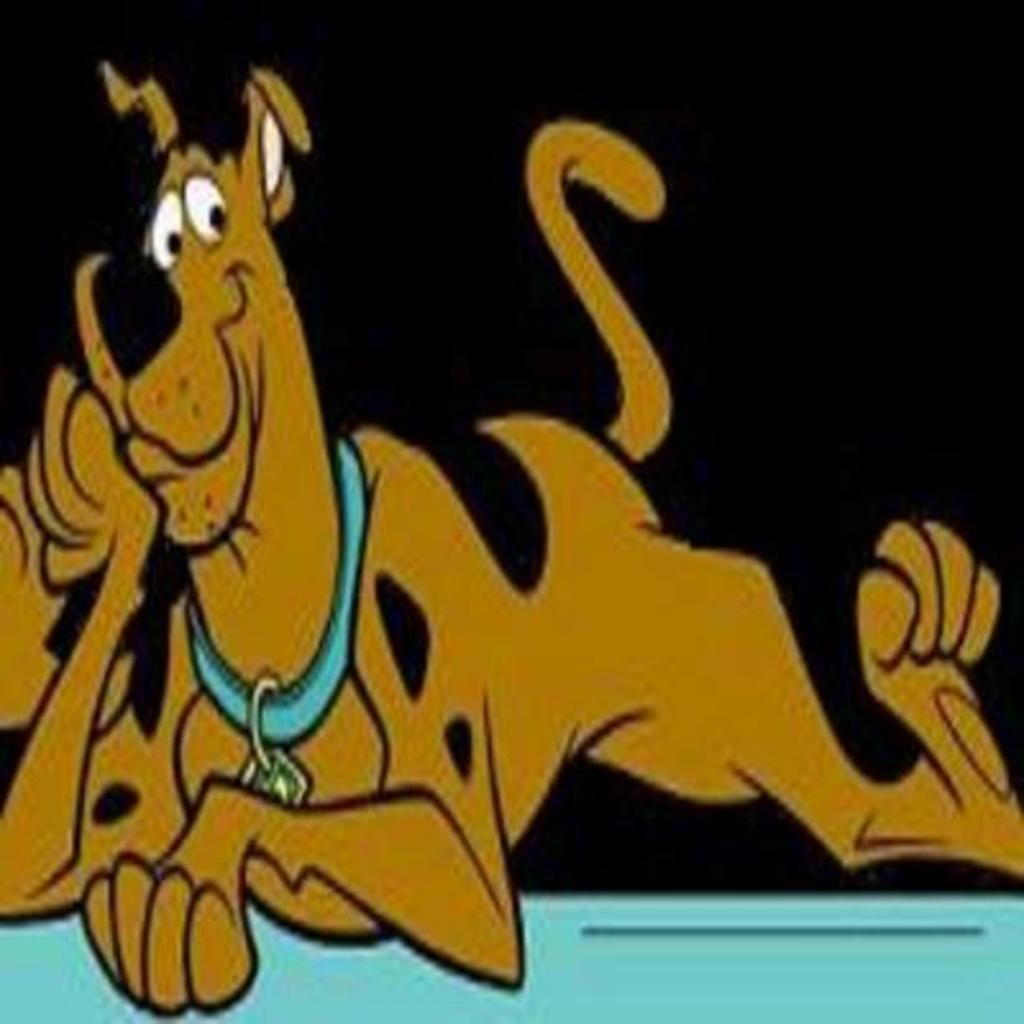What type of animal is depicted in the image? There is a cartoon picture of a dog in the image. What colors are used to represent the dog? The dog is in brown and black colors. How would you describe the overall color scheme of the image? The background of the image is dark. What type of answer is the dog providing in the image? There is no indication in the image that the dog is providing an answer to a question. 